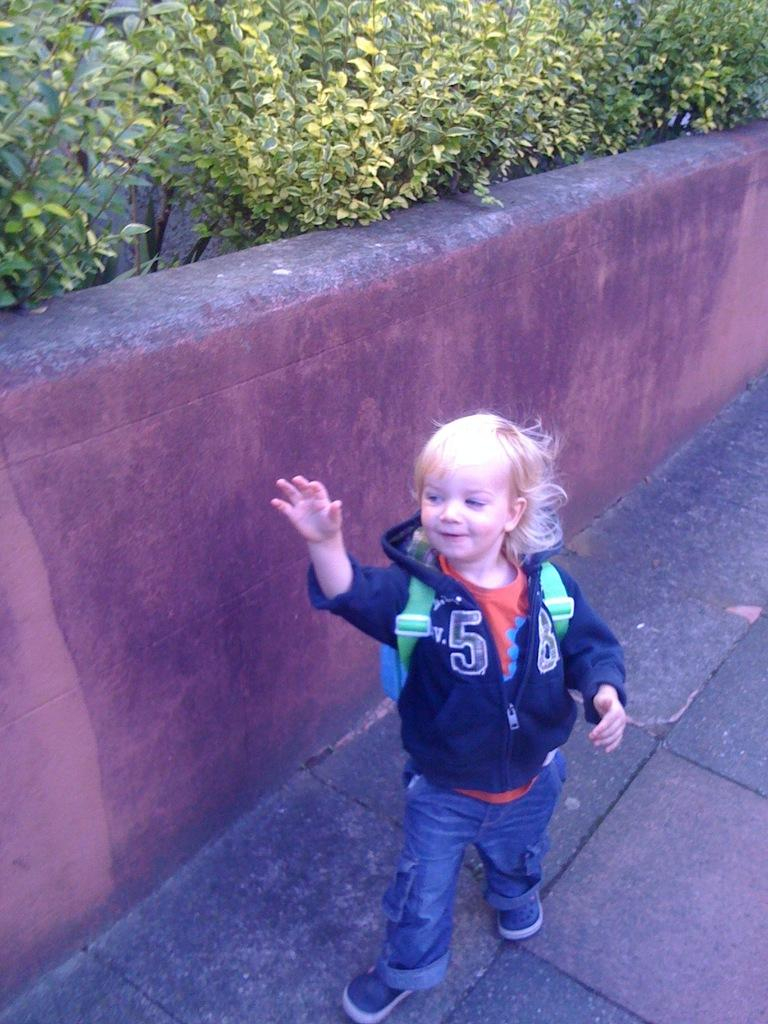Provide a one-sentence caption for the provided image. A child wearing a sweatshirt with the number 58 on it is standing in front of a wall. 